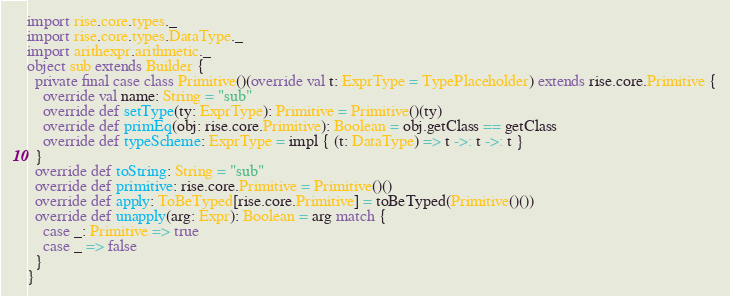<code> <loc_0><loc_0><loc_500><loc_500><_Scala_>import rise.core.types._
import rise.core.types.DataType._
import arithexpr.arithmetic._
object sub extends Builder {
  private final case class Primitive()(override val t: ExprType = TypePlaceholder) extends rise.core.Primitive {
    override val name: String = "sub"
    override def setType(ty: ExprType): Primitive = Primitive()(ty)
    override def primEq(obj: rise.core.Primitive): Boolean = obj.getClass == getClass
    override def typeScheme: ExprType = impl { (t: DataType) => t ->: t ->: t }
  }
  override def toString: String = "sub"
  override def primitive: rise.core.Primitive = Primitive()()
  override def apply: ToBeTyped[rise.core.Primitive] = toBeTyped(Primitive()())
  override def unapply(arg: Expr): Boolean = arg match {
    case _: Primitive => true
    case _ => false
  }
}
</code> 